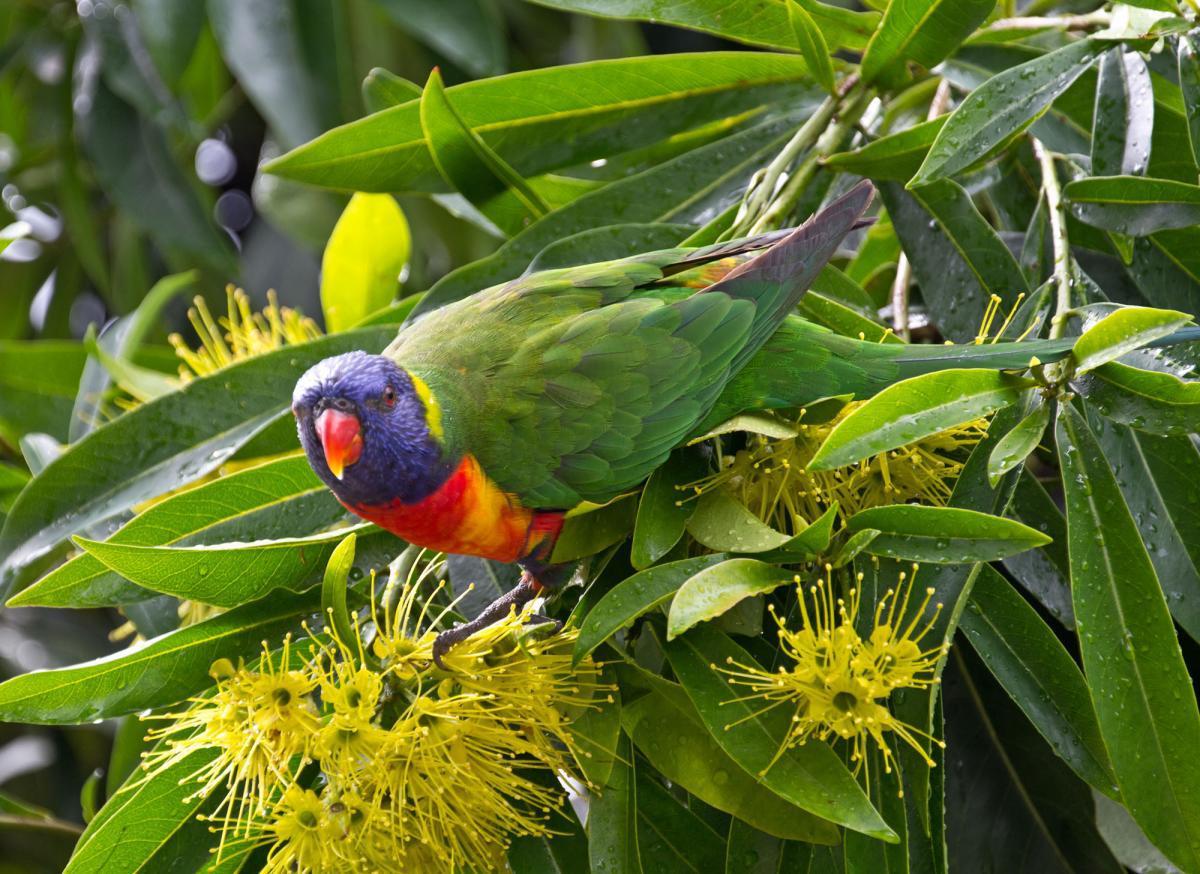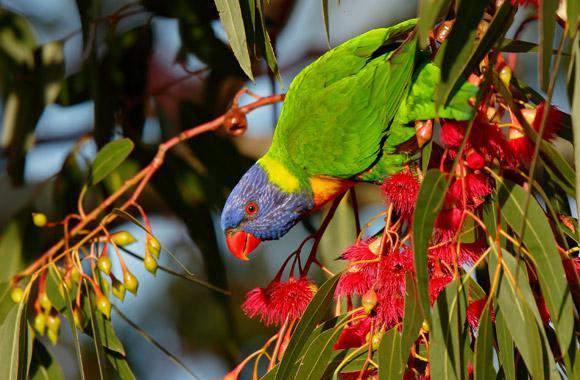The first image is the image on the left, the second image is the image on the right. Evaluate the accuracy of this statement regarding the images: "An image shows a parrot perched among branches of red flowers with tendril petals.". Is it true? Answer yes or no. Yes. The first image is the image on the left, the second image is the image on the right. For the images shown, is this caption "In one of the images there is a bird in a tree with red flowers." true? Answer yes or no. Yes. 